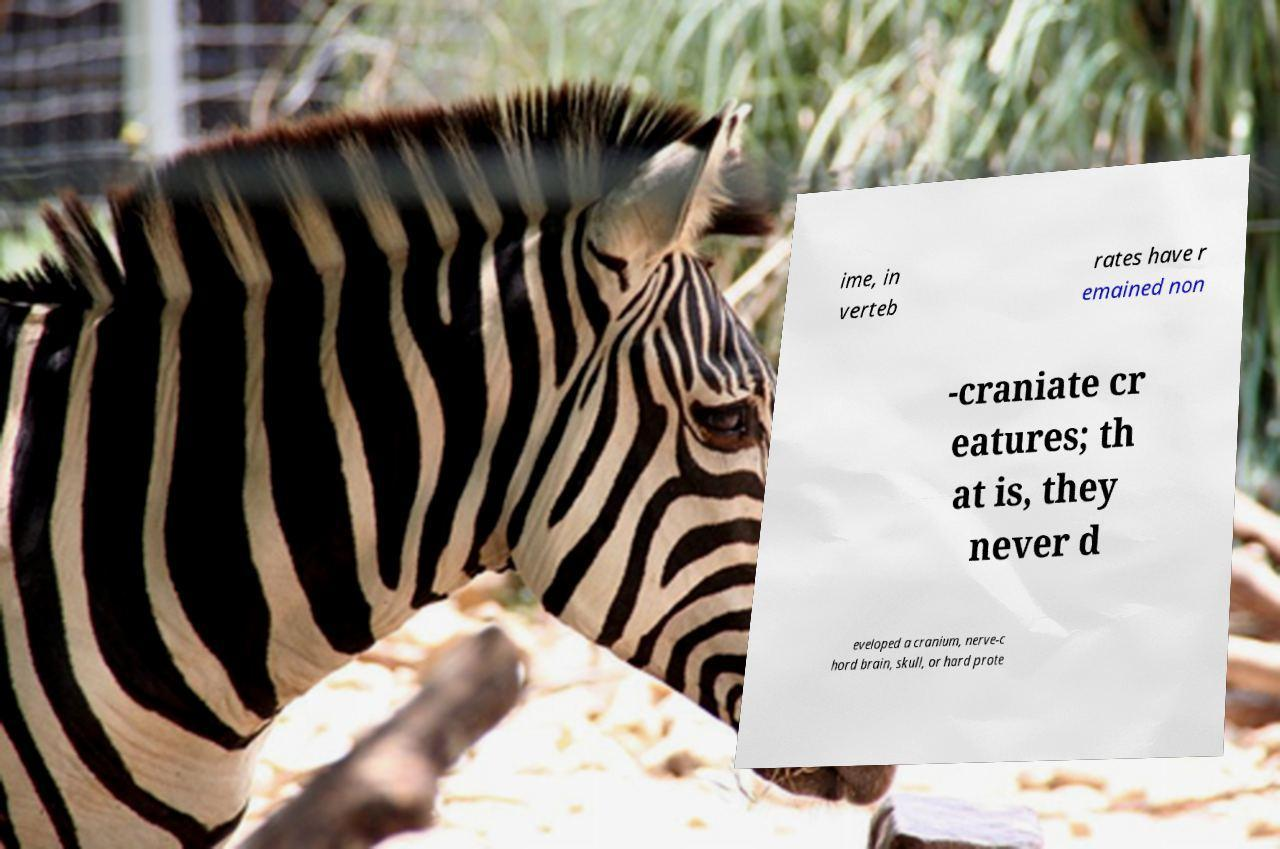Please identify and transcribe the text found in this image. ime, in verteb rates have r emained non -craniate cr eatures; th at is, they never d eveloped a cranium, nerve-c hord brain, skull, or hard prote 